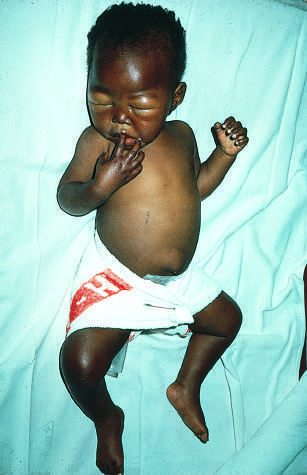what does the infant show?
Answer the question using a single word or phrase. Generalized edema 